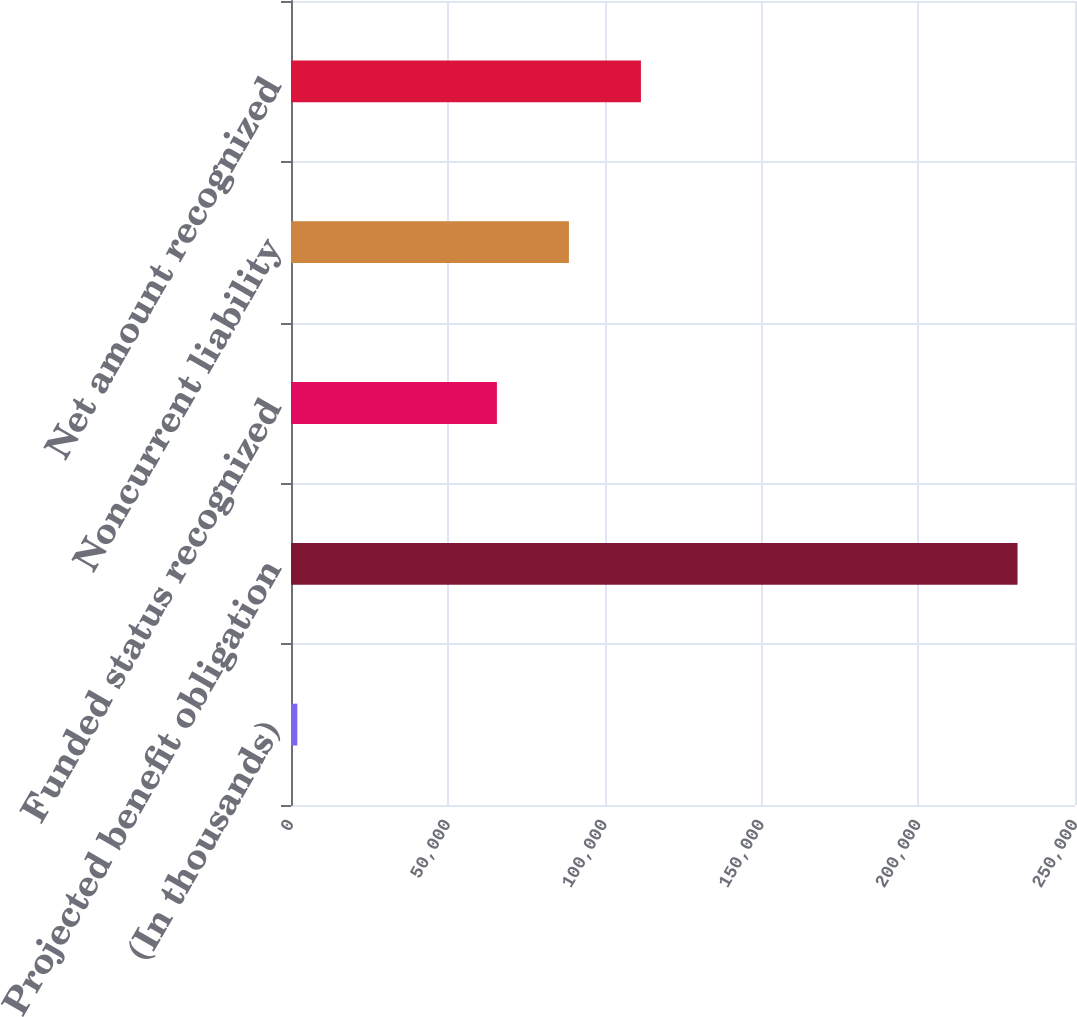Convert chart. <chart><loc_0><loc_0><loc_500><loc_500><bar_chart><fcel>(In thousands)<fcel>Projected benefit obligation<fcel>Funded status recognized<fcel>Noncurrent liability<fcel>Net amount recognized<nl><fcel>2019<fcel>231677<fcel>65657<fcel>88622.8<fcel>111589<nl></chart> 